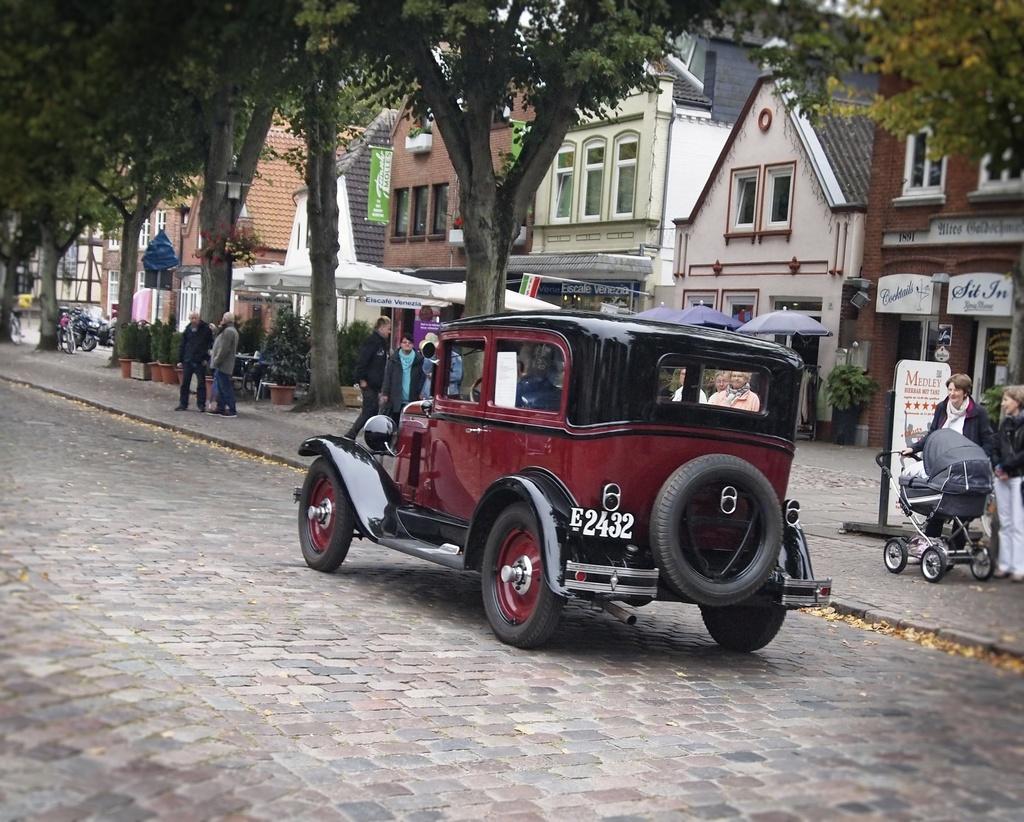In one or two sentences, can you explain what this image depicts? In this image there is a jeep on the road. Beside the jeep there is a footpath on which there are few people standing while some people are standing by holding the cradle. In the background there are buildings. In front of the buildings there are plant pots and trees. There are few vehicles which are also parked on the footpath. On the right side there is a boarding in front of the building. 